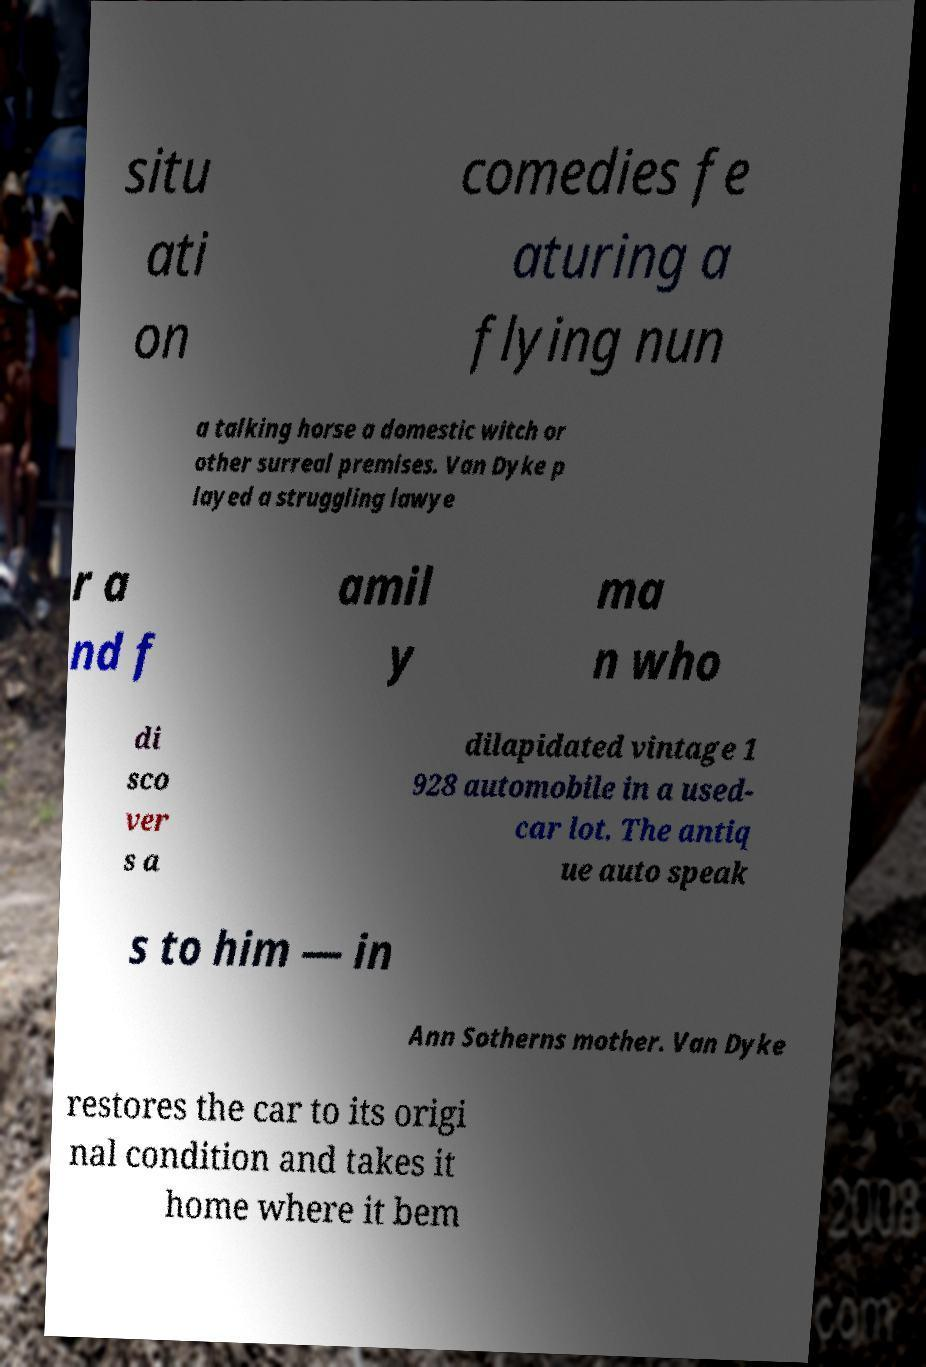Please identify and transcribe the text found in this image. situ ati on comedies fe aturing a flying nun a talking horse a domestic witch or other surreal premises. Van Dyke p layed a struggling lawye r a nd f amil y ma n who di sco ver s a dilapidated vintage 1 928 automobile in a used- car lot. The antiq ue auto speak s to him — in Ann Sotherns mother. Van Dyke restores the car to its origi nal condition and takes it home where it bem 